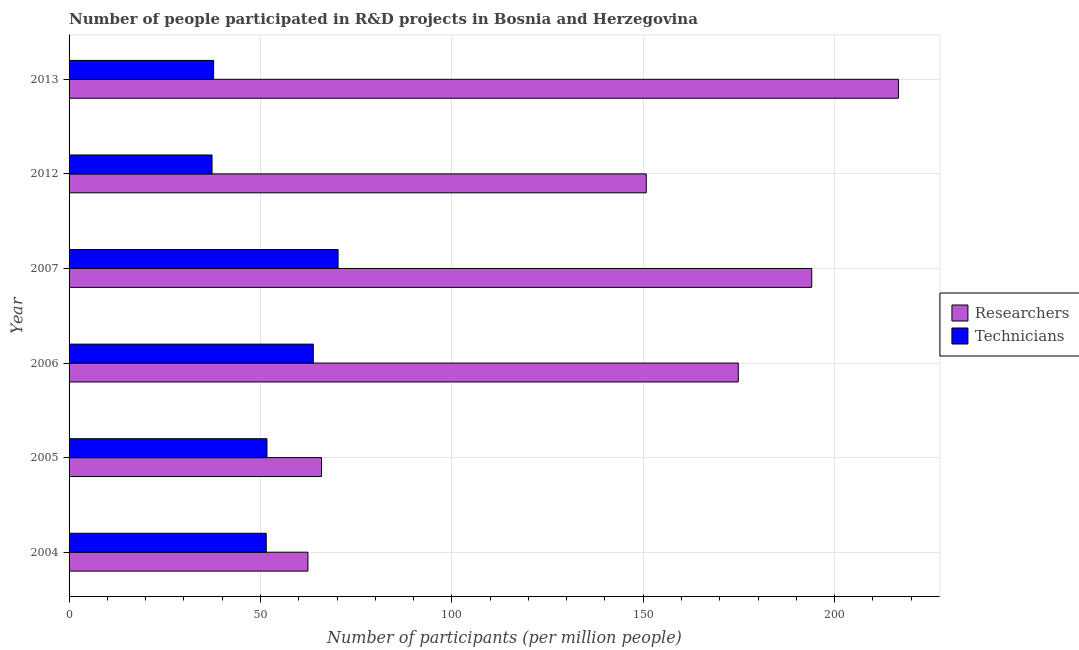How many groups of bars are there?
Your response must be concise. 6. How many bars are there on the 3rd tick from the bottom?
Give a very brief answer. 2. What is the number of researchers in 2006?
Give a very brief answer. 174.84. Across all years, what is the maximum number of technicians?
Make the answer very short. 70.28. Across all years, what is the minimum number of technicians?
Your answer should be very brief. 37.35. In which year was the number of technicians maximum?
Offer a very short reply. 2007. What is the total number of researchers in the graph?
Keep it short and to the point. 864.71. What is the difference between the number of researchers in 2004 and that in 2007?
Make the answer very short. -131.63. What is the difference between the number of technicians in 2006 and the number of researchers in 2005?
Offer a terse response. -2.15. What is the average number of technicians per year?
Your answer should be very brief. 52.07. In the year 2006, what is the difference between the number of technicians and number of researchers?
Your response must be concise. -111.04. What is the ratio of the number of technicians in 2004 to that in 2005?
Give a very brief answer. 1. Is the number of technicians in 2007 less than that in 2013?
Provide a succinct answer. No. What is the difference between the highest and the second highest number of researchers?
Provide a short and direct response. 22.65. What is the difference between the highest and the lowest number of technicians?
Offer a terse response. 32.93. In how many years, is the number of technicians greater than the average number of technicians taken over all years?
Provide a succinct answer. 2. Is the sum of the number of technicians in 2005 and 2013 greater than the maximum number of researchers across all years?
Offer a terse response. No. What does the 1st bar from the top in 2004 represents?
Offer a terse response. Technicians. What does the 1st bar from the bottom in 2012 represents?
Give a very brief answer. Researchers. How many bars are there?
Provide a succinct answer. 12. Are all the bars in the graph horizontal?
Offer a very short reply. Yes. What is the difference between two consecutive major ticks on the X-axis?
Offer a terse response. 50. Are the values on the major ticks of X-axis written in scientific E-notation?
Offer a terse response. No. How many legend labels are there?
Your answer should be compact. 2. How are the legend labels stacked?
Your response must be concise. Vertical. What is the title of the graph?
Keep it short and to the point. Number of people participated in R&D projects in Bosnia and Herzegovina. Does "Taxes" appear as one of the legend labels in the graph?
Your answer should be compact. No. What is the label or title of the X-axis?
Give a very brief answer. Number of participants (per million people). What is the Number of participants (per million people) in Researchers in 2004?
Offer a terse response. 62.41. What is the Number of participants (per million people) of Technicians in 2004?
Ensure brevity in your answer.  51.51. What is the Number of participants (per million people) in Researchers in 2005?
Provide a short and direct response. 65.95. What is the Number of participants (per million people) of Technicians in 2005?
Keep it short and to the point. 51.7. What is the Number of participants (per million people) of Researchers in 2006?
Your answer should be compact. 174.84. What is the Number of participants (per million people) in Technicians in 2006?
Provide a short and direct response. 63.8. What is the Number of participants (per million people) of Researchers in 2007?
Your response must be concise. 194.03. What is the Number of participants (per million people) in Technicians in 2007?
Offer a terse response. 70.28. What is the Number of participants (per million people) in Researchers in 2012?
Make the answer very short. 150.79. What is the Number of participants (per million people) in Technicians in 2012?
Provide a succinct answer. 37.35. What is the Number of participants (per million people) in Researchers in 2013?
Ensure brevity in your answer.  216.68. What is the Number of participants (per million people) in Technicians in 2013?
Your answer should be compact. 37.77. Across all years, what is the maximum Number of participants (per million people) in Researchers?
Your answer should be compact. 216.68. Across all years, what is the maximum Number of participants (per million people) in Technicians?
Provide a short and direct response. 70.28. Across all years, what is the minimum Number of participants (per million people) in Researchers?
Keep it short and to the point. 62.41. Across all years, what is the minimum Number of participants (per million people) of Technicians?
Your answer should be compact. 37.35. What is the total Number of participants (per million people) in Researchers in the graph?
Ensure brevity in your answer.  864.71. What is the total Number of participants (per million people) of Technicians in the graph?
Provide a succinct answer. 312.41. What is the difference between the Number of participants (per million people) in Researchers in 2004 and that in 2005?
Offer a very short reply. -3.55. What is the difference between the Number of participants (per million people) of Technicians in 2004 and that in 2005?
Ensure brevity in your answer.  -0.19. What is the difference between the Number of participants (per million people) in Researchers in 2004 and that in 2006?
Your answer should be very brief. -112.43. What is the difference between the Number of participants (per million people) in Technicians in 2004 and that in 2006?
Ensure brevity in your answer.  -12.29. What is the difference between the Number of participants (per million people) in Researchers in 2004 and that in 2007?
Your answer should be compact. -131.63. What is the difference between the Number of participants (per million people) in Technicians in 2004 and that in 2007?
Offer a terse response. -18.77. What is the difference between the Number of participants (per million people) in Researchers in 2004 and that in 2012?
Ensure brevity in your answer.  -88.39. What is the difference between the Number of participants (per million people) in Technicians in 2004 and that in 2012?
Provide a short and direct response. 14.16. What is the difference between the Number of participants (per million people) of Researchers in 2004 and that in 2013?
Provide a short and direct response. -154.28. What is the difference between the Number of participants (per million people) in Technicians in 2004 and that in 2013?
Your response must be concise. 13.74. What is the difference between the Number of participants (per million people) in Researchers in 2005 and that in 2006?
Ensure brevity in your answer.  -108.89. What is the difference between the Number of participants (per million people) in Technicians in 2005 and that in 2006?
Offer a terse response. -12.11. What is the difference between the Number of participants (per million people) of Researchers in 2005 and that in 2007?
Your answer should be compact. -128.08. What is the difference between the Number of participants (per million people) in Technicians in 2005 and that in 2007?
Your answer should be very brief. -18.59. What is the difference between the Number of participants (per million people) of Researchers in 2005 and that in 2012?
Offer a terse response. -84.84. What is the difference between the Number of participants (per million people) of Technicians in 2005 and that in 2012?
Provide a short and direct response. 14.34. What is the difference between the Number of participants (per million people) of Researchers in 2005 and that in 2013?
Your answer should be very brief. -150.73. What is the difference between the Number of participants (per million people) of Technicians in 2005 and that in 2013?
Provide a short and direct response. 13.93. What is the difference between the Number of participants (per million people) in Researchers in 2006 and that in 2007?
Ensure brevity in your answer.  -19.19. What is the difference between the Number of participants (per million people) of Technicians in 2006 and that in 2007?
Your response must be concise. -6.48. What is the difference between the Number of participants (per million people) in Researchers in 2006 and that in 2012?
Provide a succinct answer. 24.05. What is the difference between the Number of participants (per million people) of Technicians in 2006 and that in 2012?
Offer a terse response. 26.45. What is the difference between the Number of participants (per million people) in Researchers in 2006 and that in 2013?
Offer a terse response. -41.84. What is the difference between the Number of participants (per million people) of Technicians in 2006 and that in 2013?
Your answer should be compact. 26.04. What is the difference between the Number of participants (per million people) of Researchers in 2007 and that in 2012?
Your answer should be very brief. 43.24. What is the difference between the Number of participants (per million people) of Technicians in 2007 and that in 2012?
Your response must be concise. 32.93. What is the difference between the Number of participants (per million people) in Researchers in 2007 and that in 2013?
Ensure brevity in your answer.  -22.65. What is the difference between the Number of participants (per million people) of Technicians in 2007 and that in 2013?
Your answer should be very brief. 32.52. What is the difference between the Number of participants (per million people) of Researchers in 2012 and that in 2013?
Your response must be concise. -65.89. What is the difference between the Number of participants (per million people) in Technicians in 2012 and that in 2013?
Your answer should be compact. -0.41. What is the difference between the Number of participants (per million people) in Researchers in 2004 and the Number of participants (per million people) in Technicians in 2005?
Offer a terse response. 10.71. What is the difference between the Number of participants (per million people) of Researchers in 2004 and the Number of participants (per million people) of Technicians in 2006?
Offer a terse response. -1.4. What is the difference between the Number of participants (per million people) of Researchers in 2004 and the Number of participants (per million people) of Technicians in 2007?
Offer a very short reply. -7.88. What is the difference between the Number of participants (per million people) in Researchers in 2004 and the Number of participants (per million people) in Technicians in 2012?
Your answer should be compact. 25.05. What is the difference between the Number of participants (per million people) in Researchers in 2004 and the Number of participants (per million people) in Technicians in 2013?
Offer a very short reply. 24.64. What is the difference between the Number of participants (per million people) of Researchers in 2005 and the Number of participants (per million people) of Technicians in 2006?
Keep it short and to the point. 2.15. What is the difference between the Number of participants (per million people) of Researchers in 2005 and the Number of participants (per million people) of Technicians in 2007?
Offer a terse response. -4.33. What is the difference between the Number of participants (per million people) in Researchers in 2005 and the Number of participants (per million people) in Technicians in 2012?
Provide a short and direct response. 28.6. What is the difference between the Number of participants (per million people) of Researchers in 2005 and the Number of participants (per million people) of Technicians in 2013?
Give a very brief answer. 28.18. What is the difference between the Number of participants (per million people) of Researchers in 2006 and the Number of participants (per million people) of Technicians in 2007?
Make the answer very short. 104.56. What is the difference between the Number of participants (per million people) of Researchers in 2006 and the Number of participants (per million people) of Technicians in 2012?
Your answer should be compact. 137.49. What is the difference between the Number of participants (per million people) in Researchers in 2006 and the Number of participants (per million people) in Technicians in 2013?
Keep it short and to the point. 137.07. What is the difference between the Number of participants (per million people) in Researchers in 2007 and the Number of participants (per million people) in Technicians in 2012?
Give a very brief answer. 156.68. What is the difference between the Number of participants (per million people) in Researchers in 2007 and the Number of participants (per million people) in Technicians in 2013?
Provide a short and direct response. 156.27. What is the difference between the Number of participants (per million people) of Researchers in 2012 and the Number of participants (per million people) of Technicians in 2013?
Your response must be concise. 113.03. What is the average Number of participants (per million people) of Researchers per year?
Your answer should be compact. 144.12. What is the average Number of participants (per million people) of Technicians per year?
Offer a terse response. 52.07. In the year 2004, what is the difference between the Number of participants (per million people) of Researchers and Number of participants (per million people) of Technicians?
Ensure brevity in your answer.  10.89. In the year 2005, what is the difference between the Number of participants (per million people) in Researchers and Number of participants (per million people) in Technicians?
Make the answer very short. 14.25. In the year 2006, what is the difference between the Number of participants (per million people) in Researchers and Number of participants (per million people) in Technicians?
Your answer should be compact. 111.04. In the year 2007, what is the difference between the Number of participants (per million people) in Researchers and Number of participants (per million people) in Technicians?
Provide a succinct answer. 123.75. In the year 2012, what is the difference between the Number of participants (per million people) of Researchers and Number of participants (per million people) of Technicians?
Give a very brief answer. 113.44. In the year 2013, what is the difference between the Number of participants (per million people) of Researchers and Number of participants (per million people) of Technicians?
Your response must be concise. 178.92. What is the ratio of the Number of participants (per million people) of Researchers in 2004 to that in 2005?
Ensure brevity in your answer.  0.95. What is the ratio of the Number of participants (per million people) of Technicians in 2004 to that in 2005?
Your response must be concise. 1. What is the ratio of the Number of participants (per million people) in Researchers in 2004 to that in 2006?
Your response must be concise. 0.36. What is the ratio of the Number of participants (per million people) of Technicians in 2004 to that in 2006?
Make the answer very short. 0.81. What is the ratio of the Number of participants (per million people) of Researchers in 2004 to that in 2007?
Offer a very short reply. 0.32. What is the ratio of the Number of participants (per million people) in Technicians in 2004 to that in 2007?
Give a very brief answer. 0.73. What is the ratio of the Number of participants (per million people) in Researchers in 2004 to that in 2012?
Your answer should be very brief. 0.41. What is the ratio of the Number of participants (per million people) of Technicians in 2004 to that in 2012?
Offer a very short reply. 1.38. What is the ratio of the Number of participants (per million people) of Researchers in 2004 to that in 2013?
Give a very brief answer. 0.29. What is the ratio of the Number of participants (per million people) in Technicians in 2004 to that in 2013?
Offer a very short reply. 1.36. What is the ratio of the Number of participants (per million people) of Researchers in 2005 to that in 2006?
Your answer should be compact. 0.38. What is the ratio of the Number of participants (per million people) in Technicians in 2005 to that in 2006?
Offer a very short reply. 0.81. What is the ratio of the Number of participants (per million people) of Researchers in 2005 to that in 2007?
Keep it short and to the point. 0.34. What is the ratio of the Number of participants (per million people) of Technicians in 2005 to that in 2007?
Your answer should be very brief. 0.74. What is the ratio of the Number of participants (per million people) of Researchers in 2005 to that in 2012?
Ensure brevity in your answer.  0.44. What is the ratio of the Number of participants (per million people) of Technicians in 2005 to that in 2012?
Give a very brief answer. 1.38. What is the ratio of the Number of participants (per million people) of Researchers in 2005 to that in 2013?
Your answer should be compact. 0.3. What is the ratio of the Number of participants (per million people) in Technicians in 2005 to that in 2013?
Make the answer very short. 1.37. What is the ratio of the Number of participants (per million people) in Researchers in 2006 to that in 2007?
Your response must be concise. 0.9. What is the ratio of the Number of participants (per million people) in Technicians in 2006 to that in 2007?
Your response must be concise. 0.91. What is the ratio of the Number of participants (per million people) in Researchers in 2006 to that in 2012?
Offer a terse response. 1.16. What is the ratio of the Number of participants (per million people) of Technicians in 2006 to that in 2012?
Your response must be concise. 1.71. What is the ratio of the Number of participants (per million people) of Researchers in 2006 to that in 2013?
Make the answer very short. 0.81. What is the ratio of the Number of participants (per million people) in Technicians in 2006 to that in 2013?
Provide a short and direct response. 1.69. What is the ratio of the Number of participants (per million people) in Researchers in 2007 to that in 2012?
Provide a short and direct response. 1.29. What is the ratio of the Number of participants (per million people) in Technicians in 2007 to that in 2012?
Provide a short and direct response. 1.88. What is the ratio of the Number of participants (per million people) in Researchers in 2007 to that in 2013?
Offer a very short reply. 0.9. What is the ratio of the Number of participants (per million people) of Technicians in 2007 to that in 2013?
Make the answer very short. 1.86. What is the ratio of the Number of participants (per million people) of Researchers in 2012 to that in 2013?
Give a very brief answer. 0.7. What is the difference between the highest and the second highest Number of participants (per million people) of Researchers?
Provide a short and direct response. 22.65. What is the difference between the highest and the second highest Number of participants (per million people) in Technicians?
Your answer should be very brief. 6.48. What is the difference between the highest and the lowest Number of participants (per million people) of Researchers?
Keep it short and to the point. 154.28. What is the difference between the highest and the lowest Number of participants (per million people) in Technicians?
Offer a terse response. 32.93. 